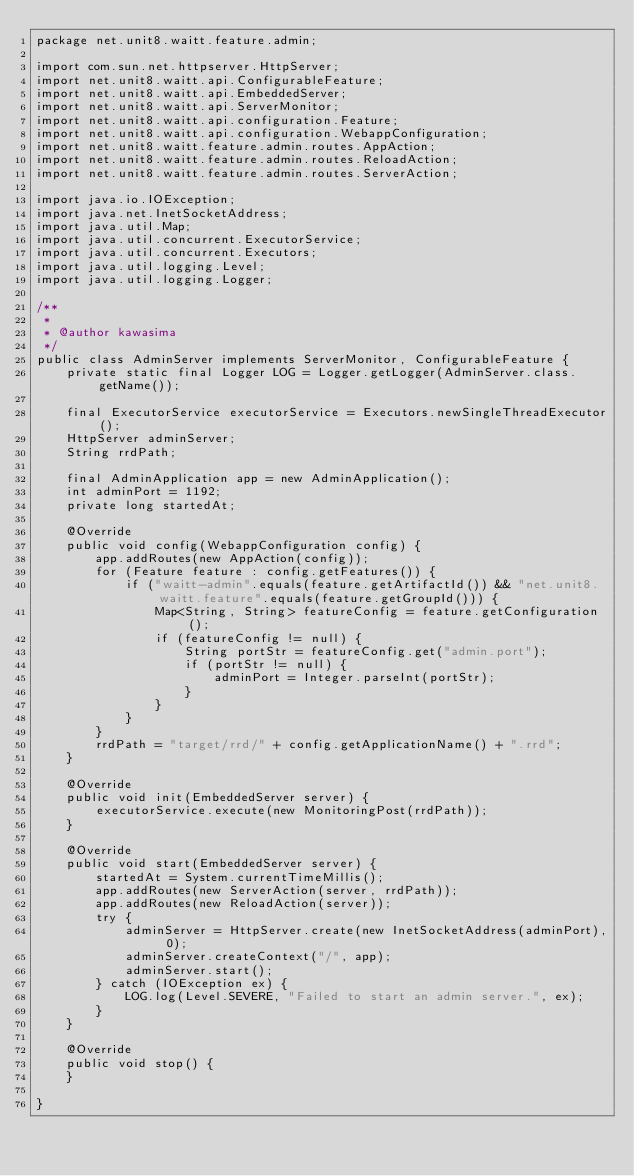Convert code to text. <code><loc_0><loc_0><loc_500><loc_500><_Java_>package net.unit8.waitt.feature.admin;

import com.sun.net.httpserver.HttpServer;
import net.unit8.waitt.api.ConfigurableFeature;
import net.unit8.waitt.api.EmbeddedServer;
import net.unit8.waitt.api.ServerMonitor;
import net.unit8.waitt.api.configuration.Feature;
import net.unit8.waitt.api.configuration.WebappConfiguration;
import net.unit8.waitt.feature.admin.routes.AppAction;
import net.unit8.waitt.feature.admin.routes.ReloadAction;
import net.unit8.waitt.feature.admin.routes.ServerAction;

import java.io.IOException;
import java.net.InetSocketAddress;
import java.util.Map;
import java.util.concurrent.ExecutorService;
import java.util.concurrent.Executors;
import java.util.logging.Level;
import java.util.logging.Logger;

/**
 *
 * @author kawasima
 */
public class AdminServer implements ServerMonitor, ConfigurableFeature {
    private static final Logger LOG = Logger.getLogger(AdminServer.class.getName());

    final ExecutorService executorService = Executors.newSingleThreadExecutor();
    HttpServer adminServer;
    String rrdPath;

    final AdminApplication app = new AdminApplication();
    int adminPort = 1192;
    private long startedAt;

    @Override
    public void config(WebappConfiguration config) {
        app.addRoutes(new AppAction(config));
        for (Feature feature : config.getFeatures()) {
            if ("waitt-admin".equals(feature.getArtifactId()) && "net.unit8.waitt.feature".equals(feature.getGroupId())) {
                Map<String, String> featureConfig = feature.getConfiguration();
                if (featureConfig != null) {
                    String portStr = featureConfig.get("admin.port");
                    if (portStr != null) {
                        adminPort = Integer.parseInt(portStr);
                    }
                }
            }
        }
        rrdPath = "target/rrd/" + config.getApplicationName() + ".rrd";
    }

    @Override
    public void init(EmbeddedServer server) {
        executorService.execute(new MonitoringPost(rrdPath));
    }

    @Override
    public void start(EmbeddedServer server) {
        startedAt = System.currentTimeMillis();
        app.addRoutes(new ServerAction(server, rrdPath));
        app.addRoutes(new ReloadAction(server));
        try {
            adminServer = HttpServer.create(new InetSocketAddress(adminPort), 0);
            adminServer.createContext("/", app);
            adminServer.start();
        } catch (IOException ex) {
            LOG.log(Level.SEVERE, "Failed to start an admin server.", ex);
        }
    }

    @Override
    public void stop() {
    }

}
</code> 